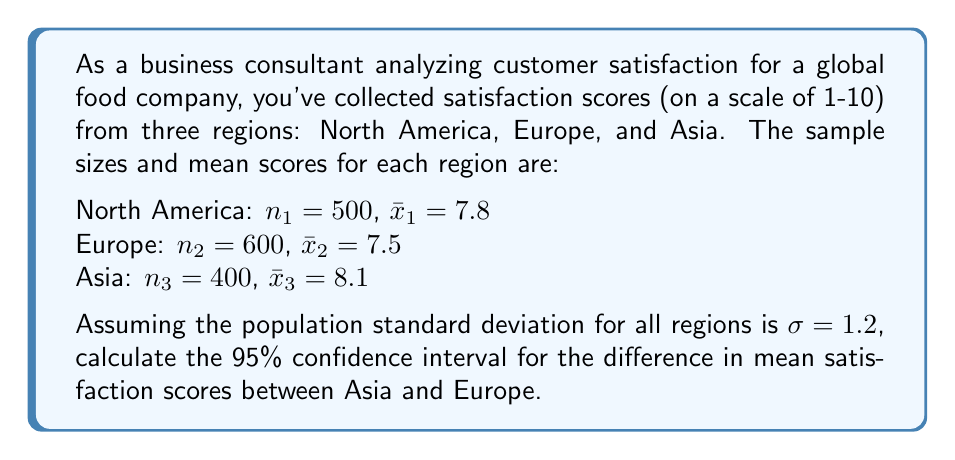Help me with this question. To calculate the confidence interval for the difference between two means, we'll follow these steps:

1) The formula for the confidence interval is:
   $$(\bar{x}_1 - \bar{x}_2) \pm z_{\alpha/2} \sqrt{\frac{\sigma^2}{n_1} + \frac{\sigma^2}{n_2}}$$

   Where $\bar{x}_1$ and $\bar{x}_2$ are the sample means, $n_1$ and $n_2$ are the sample sizes, $\sigma$ is the population standard deviation, and $z_{\alpha/2}$ is the z-score for the desired confidence level.

2) For Asia: $\bar{x}_1 = 8.1$, $n_1 = 400$
   For Europe: $\bar{x}_2 = 7.5$, $n_2 = 600$
   $\sigma = 1.2$ for both regions

3) For a 95% confidence interval, $z_{\alpha/2} = 1.96$

4) Calculate the difference in means:
   $8.1 - 7.5 = 0.6$

5) Calculate the standard error:
   $$SE = \sqrt{\frac{1.2^2}{400} + \frac{1.2^2}{600}} = \sqrt{0.0036 + 0.0024} = \sqrt{0.006} = 0.0775$$

6) Calculate the margin of error:
   $1.96 * 0.0775 = 0.1519$

7) The confidence interval is:
   $0.6 \pm 0.1519$
   
   Lower bound: $0.6 - 0.1519 = 0.4481$
   Upper bound: $0.6 + 0.1519 = 0.7519$
Answer: (0.4481, 0.7519) 